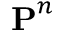<formula> <loc_0><loc_0><loc_500><loc_500>P ^ { n }</formula> 